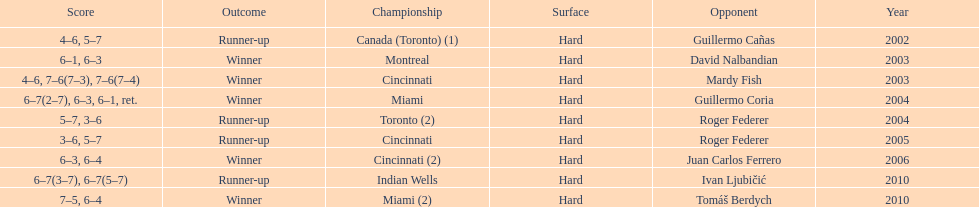How many times was roger federer a runner-up? 2. 